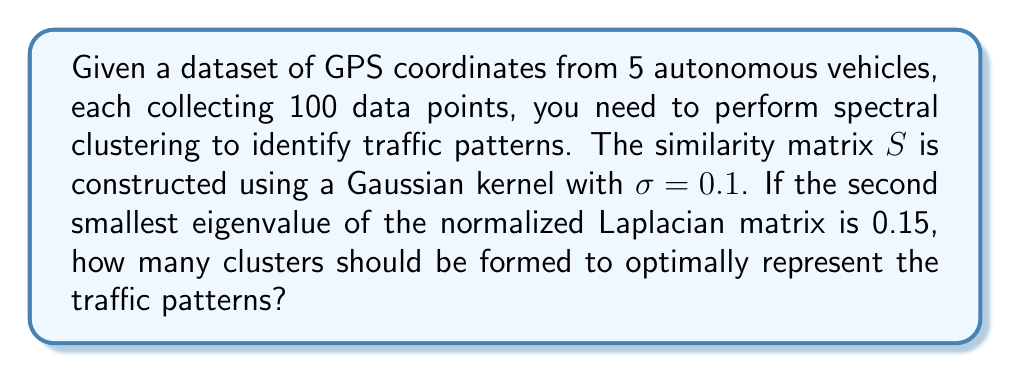Show me your answer to this math problem. To solve this problem, we'll follow these steps:

1) First, recall that spectral clustering uses the eigenvalues of the normalized Laplacian matrix to determine the number of clusters.

2) The normalized Laplacian matrix $L_{sym}$ is defined as:

   $$L_{sym} = I - D^{-1/2}SD^{-1/2}$$

   where $I$ is the identity matrix, $S$ is the similarity matrix, and $D$ is the degree matrix.

3) The eigenvalues of $L_{sym}$ are always in the range $[0, 2]$, with the smallest eigenvalue always being 0.

4) The number of eigenvalues close to 0 indicates the number of well-separated clusters in the data.

5) In practice, we look for a "gap" in the eigenvalue spectrum. The optimal number of clusters is often determined by the number of eigenvalues before a significant jump in value.

6) Given that the second smallest eigenvalue is 0.15, which is relatively close to 0, this suggests that there are two well-separated clusters in the data.

7) If there were more clusters, we would expect to see more eigenvalues close to 0 before a significant jump.

Therefore, based on the spectral properties of the normalized Laplacian, the optimal number of clusters to represent the traffic patterns is 2.
Answer: 2 clusters 